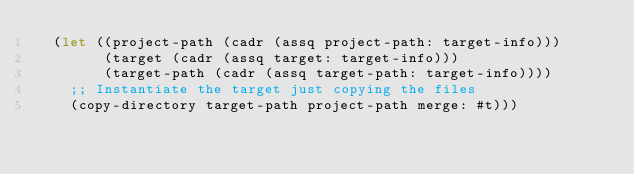<code> <loc_0><loc_0><loc_500><loc_500><_Scheme_>  (let ((project-path (cadr (assq project-path: target-info)))
        (target (cadr (assq target: target-info)))
        (target-path (cadr (assq target-path: target-info))))
    ;; Instantiate the target just copying the files
    (copy-directory target-path project-path merge: #t)))

</code> 